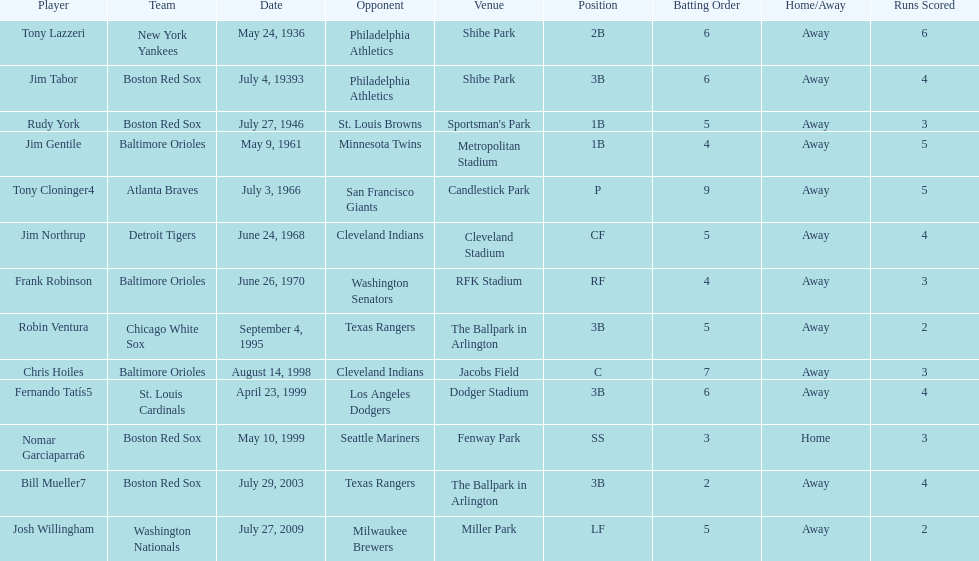What is the number of times a boston red sox player has had two grand slams in one game? 4. 